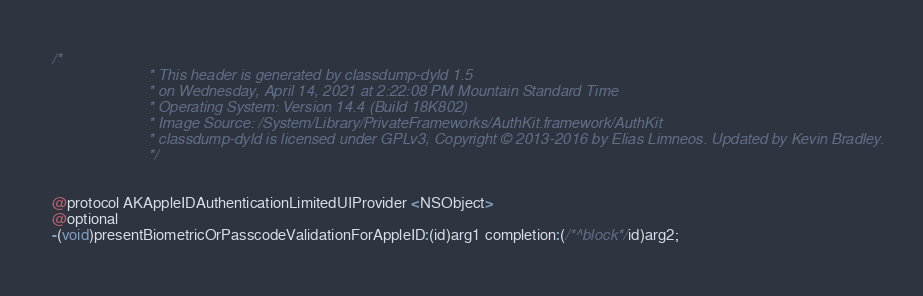<code> <loc_0><loc_0><loc_500><loc_500><_C_>/*
                       * This header is generated by classdump-dyld 1.5
                       * on Wednesday, April 14, 2021 at 2:22:08 PM Mountain Standard Time
                       * Operating System: Version 14.4 (Build 18K802)
                       * Image Source: /System/Library/PrivateFrameworks/AuthKit.framework/AuthKit
                       * classdump-dyld is licensed under GPLv3, Copyright © 2013-2016 by Elias Limneos. Updated by Kevin Bradley.
                       */


@protocol AKAppleIDAuthenticationLimitedUIProvider <NSObject>
@optional
-(void)presentBiometricOrPasscodeValidationForAppleID:(id)arg1 completion:(/*^block*/id)arg2;
</code> 